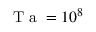Convert formula to latex. <formula><loc_0><loc_0><loc_500><loc_500>T a = 1 0 ^ { 8 }</formula> 